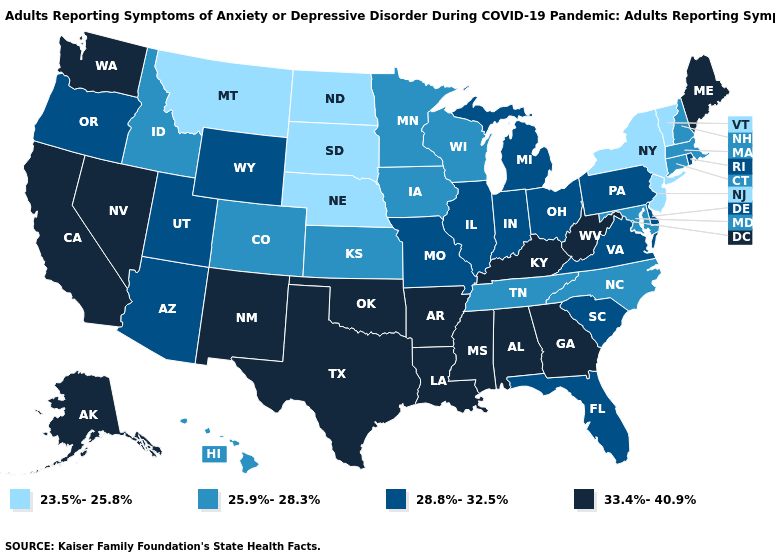Does Indiana have the highest value in the MidWest?
Give a very brief answer. Yes. Which states have the lowest value in the Northeast?
Be succinct. New Jersey, New York, Vermont. Name the states that have a value in the range 25.9%-28.3%?
Quick response, please. Colorado, Connecticut, Hawaii, Idaho, Iowa, Kansas, Maryland, Massachusetts, Minnesota, New Hampshire, North Carolina, Tennessee, Wisconsin. Which states have the lowest value in the USA?
Short answer required. Montana, Nebraska, New Jersey, New York, North Dakota, South Dakota, Vermont. What is the value of Hawaii?
Short answer required. 25.9%-28.3%. Does Wisconsin have the lowest value in the USA?
Quick response, please. No. How many symbols are there in the legend?
Give a very brief answer. 4. How many symbols are there in the legend?
Quick response, please. 4. Does the first symbol in the legend represent the smallest category?
Answer briefly. Yes. Which states have the highest value in the USA?
Write a very short answer. Alabama, Alaska, Arkansas, California, Georgia, Kentucky, Louisiana, Maine, Mississippi, Nevada, New Mexico, Oklahoma, Texas, Washington, West Virginia. Which states have the lowest value in the South?
Write a very short answer. Maryland, North Carolina, Tennessee. Does North Carolina have the highest value in the South?
Concise answer only. No. What is the value of New York?
Answer briefly. 23.5%-25.8%. Among the states that border Colorado , which have the highest value?
Write a very short answer. New Mexico, Oklahoma. What is the highest value in states that border Nebraska?
Answer briefly. 28.8%-32.5%. 